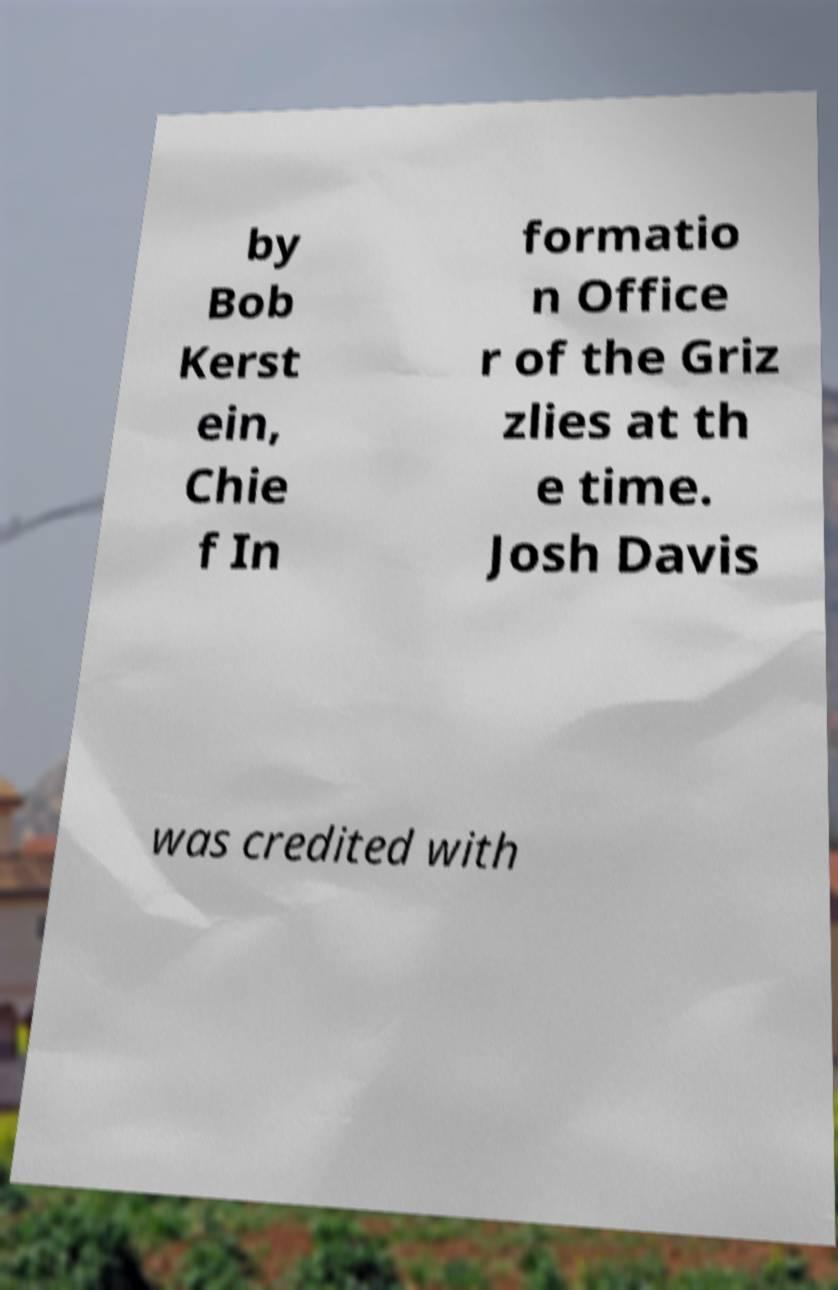Can you read and provide the text displayed in the image?This photo seems to have some interesting text. Can you extract and type it out for me? by Bob Kerst ein, Chie f In formatio n Office r of the Griz zlies at th e time. Josh Davis was credited with 